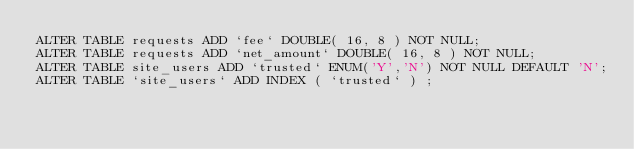<code> <loc_0><loc_0><loc_500><loc_500><_SQL_>ALTER TABLE requests ADD `fee` DOUBLE( 16, 8 ) NOT NULL;
ALTER TABLE requests ADD `net_amount` DOUBLE( 16, 8 ) NOT NULL;
ALTER TABLE site_users ADD `trusted` ENUM('Y','N') NOT NULL DEFAULT 'N';
ALTER TABLE `site_users` ADD INDEX ( `trusted` ) ;</code> 